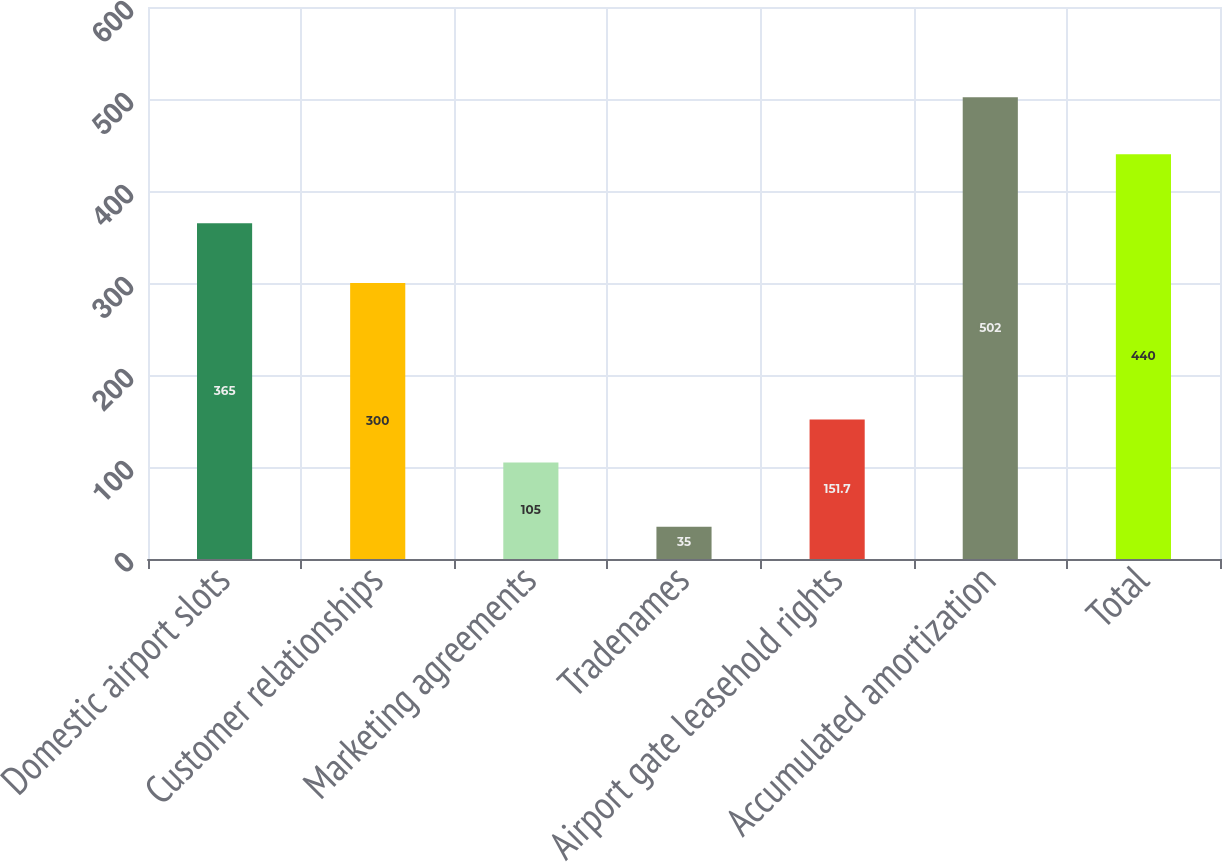Convert chart to OTSL. <chart><loc_0><loc_0><loc_500><loc_500><bar_chart><fcel>Domestic airport slots<fcel>Customer relationships<fcel>Marketing agreements<fcel>Tradenames<fcel>Airport gate leasehold rights<fcel>Accumulated amortization<fcel>Total<nl><fcel>365<fcel>300<fcel>105<fcel>35<fcel>151.7<fcel>502<fcel>440<nl></chart> 